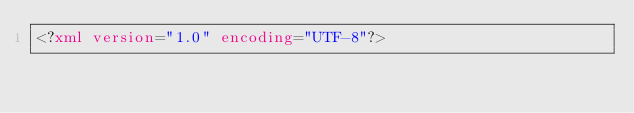<code> <loc_0><loc_0><loc_500><loc_500><_XML_><?xml version="1.0" encoding="UTF-8"?></code> 